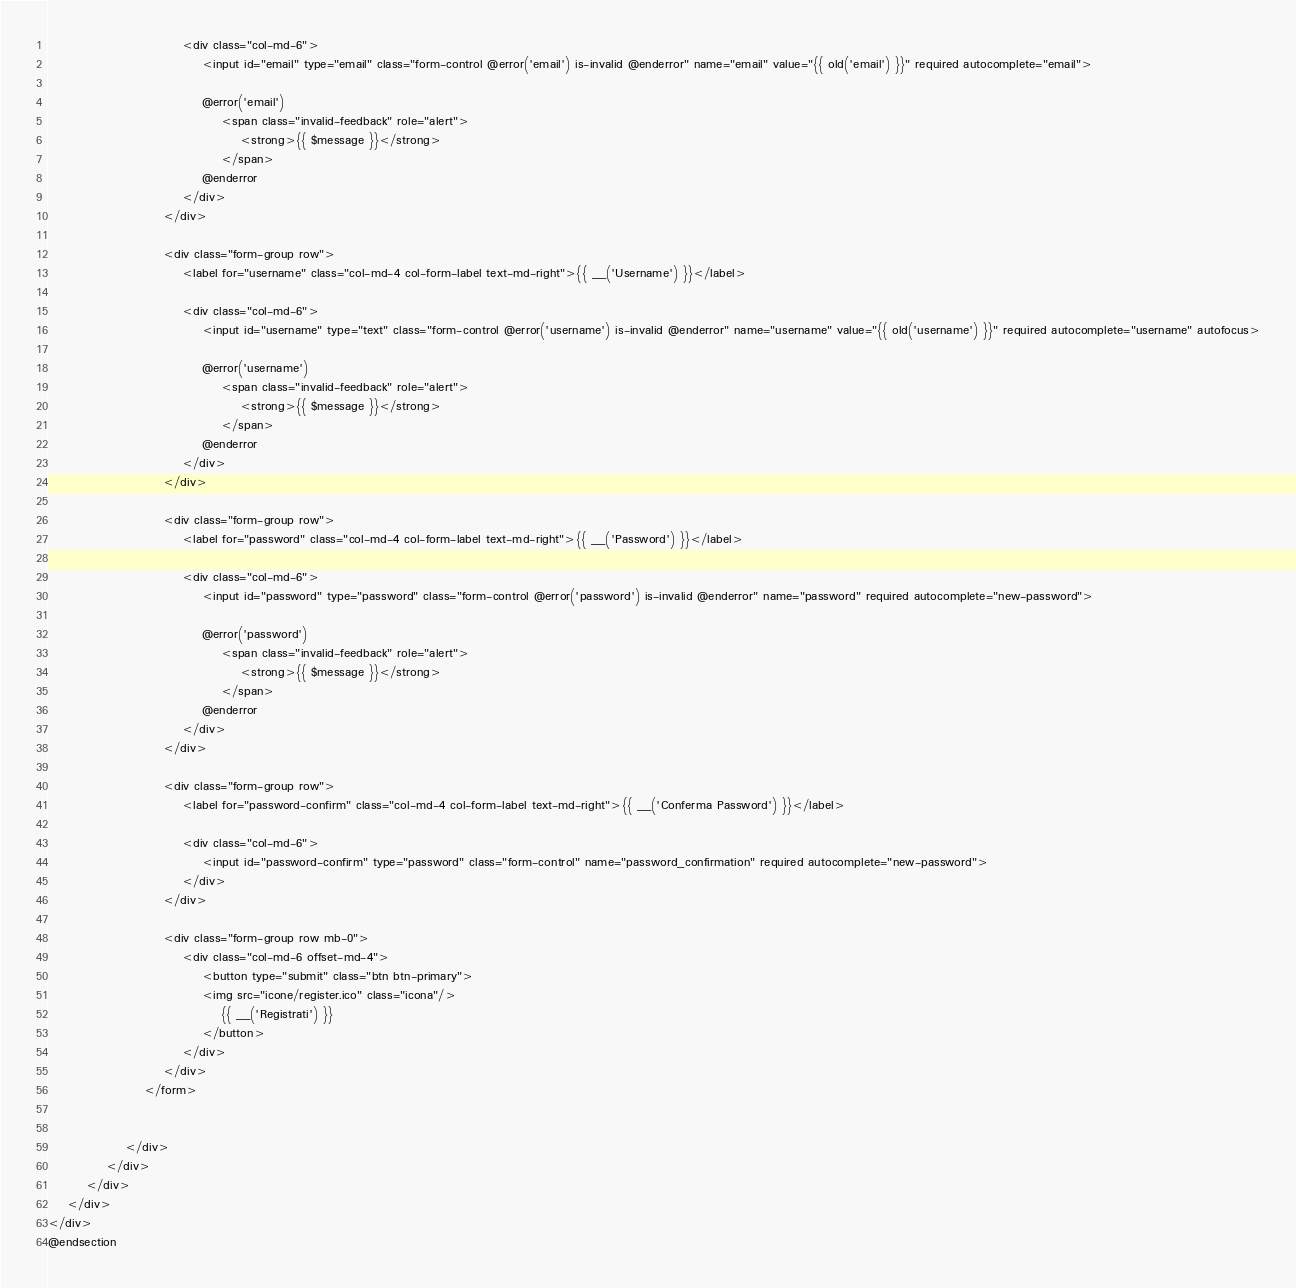<code> <loc_0><loc_0><loc_500><loc_500><_PHP_>                            <div class="col-md-6">
                                <input id="email" type="email" class="form-control @error('email') is-invalid @enderror" name="email" value="{{ old('email') }}" required autocomplete="email">

                                @error('email')
                                    <span class="invalid-feedback" role="alert">
                                        <strong>{{ $message }}</strong>
                                    </span>
                                @enderror
                            </div>
                        </div>

                        <div class="form-group row">
                            <label for="username" class="col-md-4 col-form-label text-md-right">{{ __('Username') }}</label>

                            <div class="col-md-6">
                                <input id="username" type="text" class="form-control @error('username') is-invalid @enderror" name="username" value="{{ old('username') }}" required autocomplete="username" autofocus>

                                @error('username')
                                    <span class="invalid-feedback" role="alert">
                                        <strong>{{ $message }}</strong>
                                    </span>
                                @enderror
                            </div>
                        </div>

                        <div class="form-group row">
                            <label for="password" class="col-md-4 col-form-label text-md-right">{{ __('Password') }}</label>

                            <div class="col-md-6">
                                <input id="password" type="password" class="form-control @error('password') is-invalid @enderror" name="password" required autocomplete="new-password">

                                @error('password')
                                    <span class="invalid-feedback" role="alert">
                                        <strong>{{ $message }}</strong>
                                    </span>
                                @enderror
                            </div>
                        </div>

                        <div class="form-group row">
                            <label for="password-confirm" class="col-md-4 col-form-label text-md-right">{{ __('Conferma Password') }}</label>

                            <div class="col-md-6">
                                <input id="password-confirm" type="password" class="form-control" name="password_confirmation" required autocomplete="new-password">
                            </div>
                        </div>

                        <div class="form-group row mb-0">
                            <div class="col-md-6 offset-md-4">
                                <button type="submit" class="btn btn-primary">
                                <img src="icone/register.ico" class="icona"/>
                                    {{ __('Registrati') }} 
                                </button>
                            </div>
                        </div>
                    </form>

                  
                </div>
            </div>
        </div>
    </div>
</div>
@endsection
</code> 